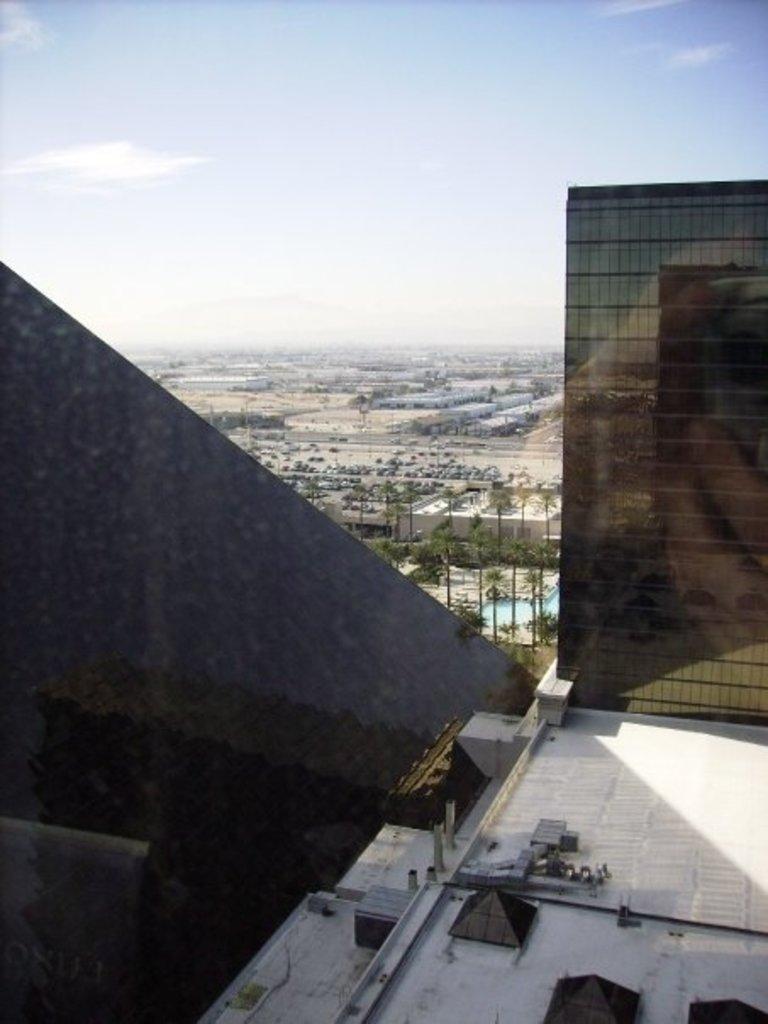In one or two sentences, can you explain what this image depicts? In this image I can see the roof of the building. In the background I can see few trees, few buildings and the sky. 